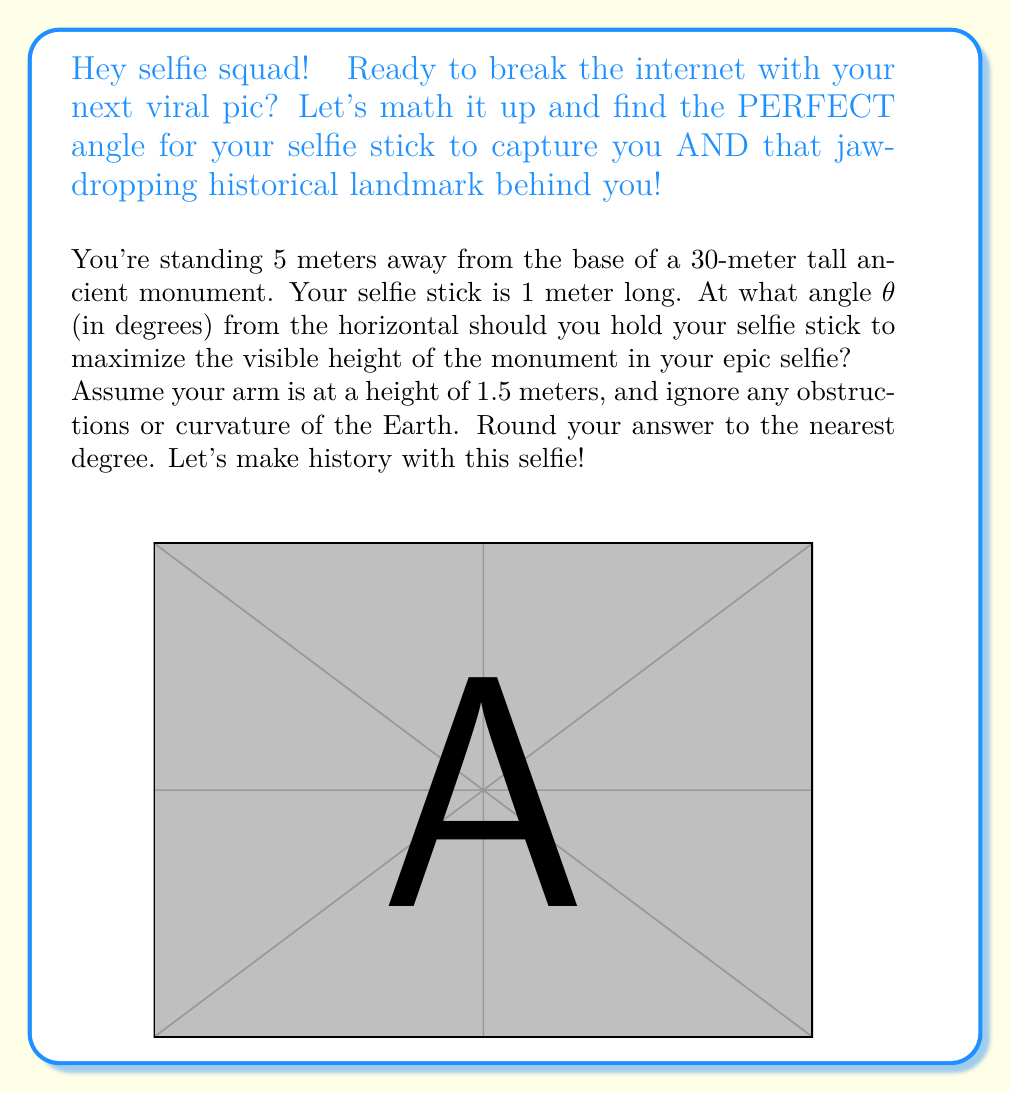Can you solve this math problem? Let's break this down step-by-step to find the optimal angle for that perfect selfie!

1) First, let's set up our coordinate system. Let the base of the monument be at (5,0) and its top at (5,30).

2) Your position is at (0,1.5) since you're 5 meters away from the base and your arm is 1.5 meters high.

3) The end of your selfie stick will be at (x,y), where:
   $x = 1 \cos θ$
   $y = 1.5 + 1 \sin θ$

4) The line from the end of your selfie stick to the top of the monument has a slope of:
   $m = \frac{30 - (1.5 + \sin θ)}{5 - \cos θ}$

5) To maximize the visible height, we need to maximize this slope. In calculus, we'd do this by taking the derivative and setting it to zero. But since we're in precalculus, we can use the fact that the maximum slope will occur when this line is perpendicular to the selfie stick.

6) The selfie stick has a slope of $\tan θ$. For perpendicularity, we need:
   $m \cdot \tan θ = -1$

7) Substituting and simplifying:
   $\frac{30 - (1.5 + \sin θ)}{5 - \cos θ} \cdot \tan θ = -1$

8) This simplifies to:
   $(30 - 1.5 - \sin θ) \sin θ = -(5 - \cos θ) \cos θ$

9) Expanding:
   $28.5 \sin θ - \sin^2 θ = -5 \cos θ + \cos^2 θ$

10) Using the identity $\sin^2 θ + \cos^2 θ = 1$:
    $28.5 \sin θ + 5 \cos θ = 1$

11) This can be solved numerically to give θ ≈ 38.1°

Rounding to the nearest degree, we get 38°.
Answer: 38° 